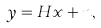<formula> <loc_0><loc_0><loc_500><loc_500>y & = H x + n ,</formula> 